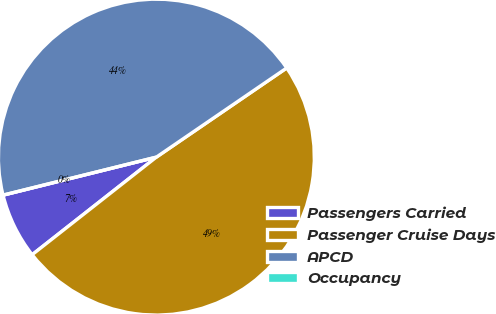Convert chart. <chart><loc_0><loc_0><loc_500><loc_500><pie_chart><fcel>Passengers Carried<fcel>Passenger Cruise Days<fcel>APCD<fcel>Occupancy<nl><fcel>6.73%<fcel>48.95%<fcel>44.32%<fcel>0.0%<nl></chart> 